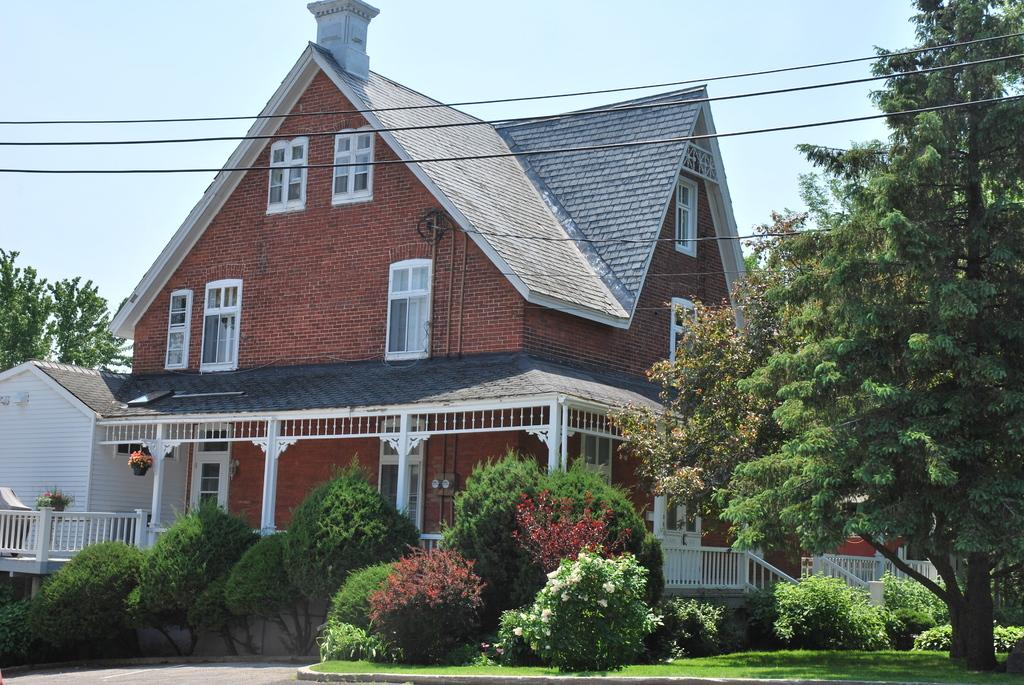What type of vegetation can be seen in the image? There are plants, grass, and trees in the image. What type of structures are present in the image? There are houses in the image. What type of barrier can be seen in the image? There is a fence in the image. What else can be seen in the image besides vegetation and structures? There are wires and other objects in the image. What is visible in the background of the image? The sky is visible in the background of the image. Can you tell me how many potatoes are being carried by the pig in the image? There is no pig or potato present in the image. What type of vehicle is parked near the houses in the image? The provided facts do not mention a vehicle, so we cannot determine if there is a van or any other type of vehicle in the image. 